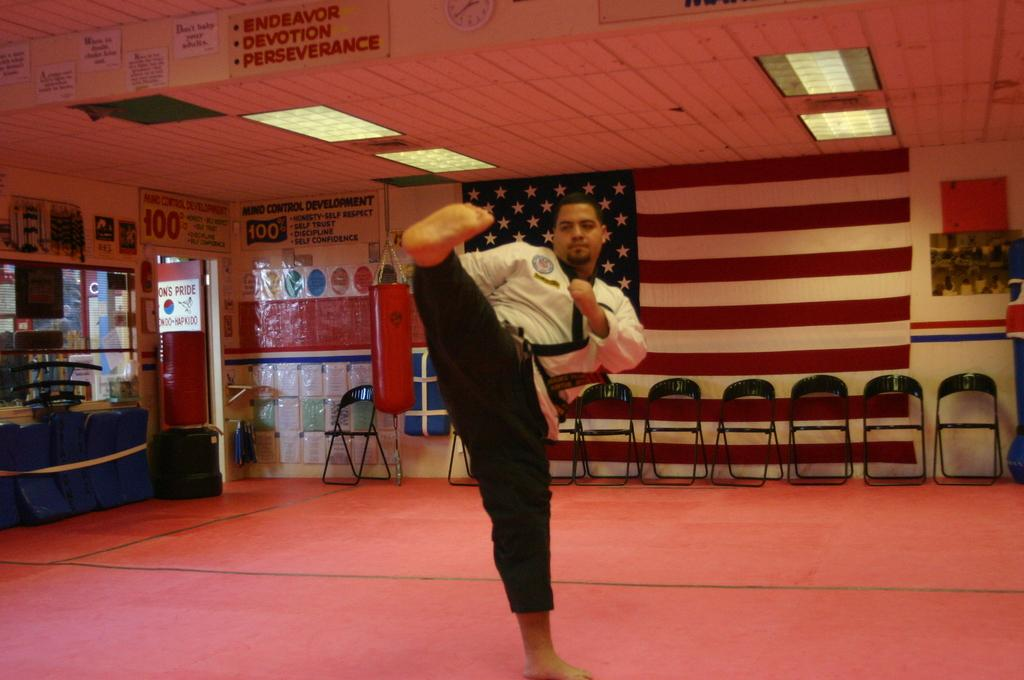Provide a one-sentence caption for the provided image. A man demonstrates a karate kick under a banner that promotes perseverance. 